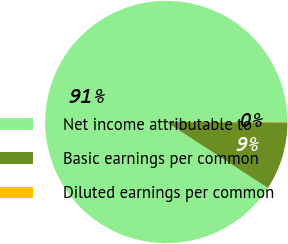Convert chart to OTSL. <chart><loc_0><loc_0><loc_500><loc_500><pie_chart><fcel>Net income attributable to<fcel>Basic earnings per common<fcel>Diluted earnings per common<nl><fcel>90.81%<fcel>9.13%<fcel>0.06%<nl></chart> 